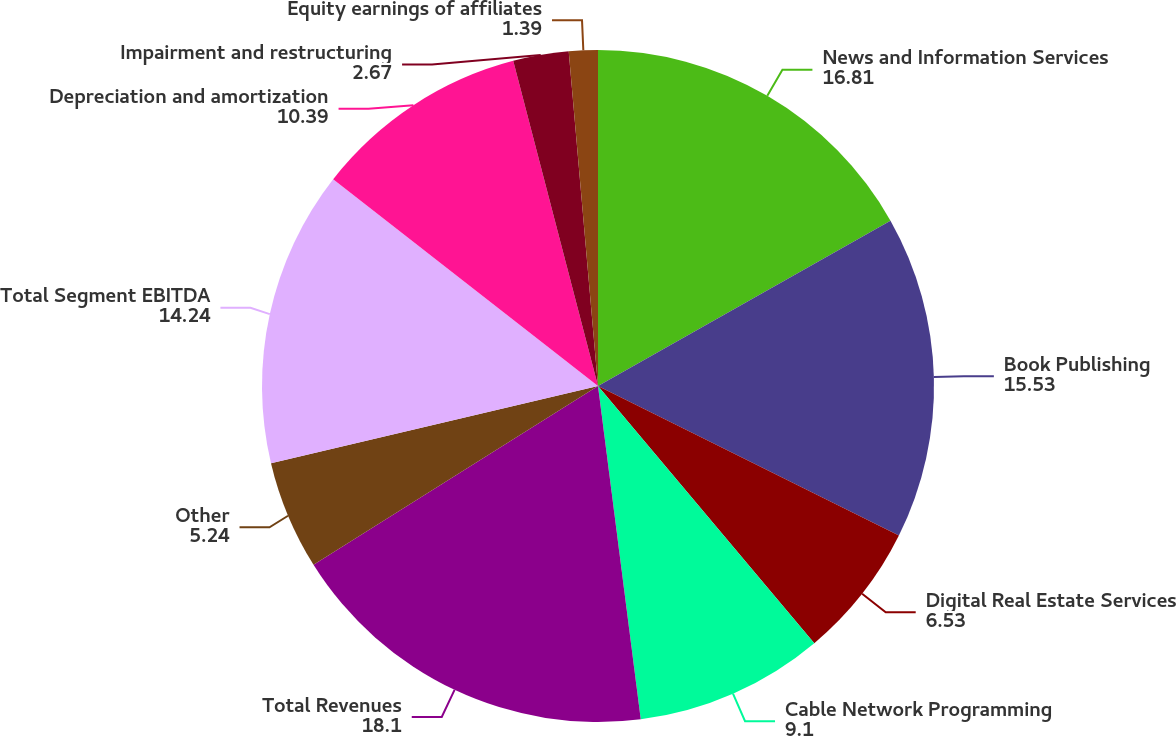Convert chart to OTSL. <chart><loc_0><loc_0><loc_500><loc_500><pie_chart><fcel>News and Information Services<fcel>Book Publishing<fcel>Digital Real Estate Services<fcel>Cable Network Programming<fcel>Total Revenues<fcel>Other<fcel>Total Segment EBITDA<fcel>Depreciation and amortization<fcel>Impairment and restructuring<fcel>Equity earnings of affiliates<nl><fcel>16.81%<fcel>15.53%<fcel>6.53%<fcel>9.1%<fcel>18.1%<fcel>5.24%<fcel>14.24%<fcel>10.39%<fcel>2.67%<fcel>1.39%<nl></chart> 